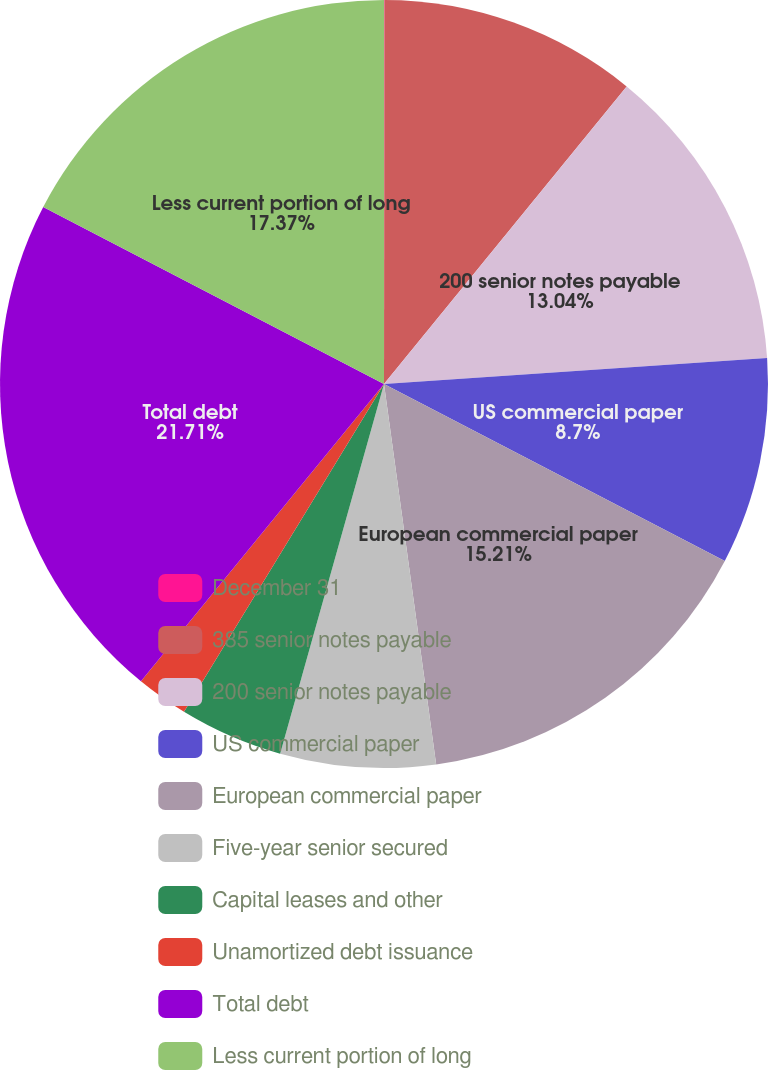Convert chart to OTSL. <chart><loc_0><loc_0><loc_500><loc_500><pie_chart><fcel>December 31<fcel>385 senior notes payable<fcel>200 senior notes payable<fcel>US commercial paper<fcel>European commercial paper<fcel>Five-year senior secured<fcel>Capital leases and other<fcel>Unamortized debt issuance<fcel>Total debt<fcel>Less current portion of long<nl><fcel>0.02%<fcel>10.87%<fcel>13.04%<fcel>8.7%<fcel>15.21%<fcel>6.53%<fcel>4.36%<fcel>2.19%<fcel>21.72%<fcel>17.38%<nl></chart> 